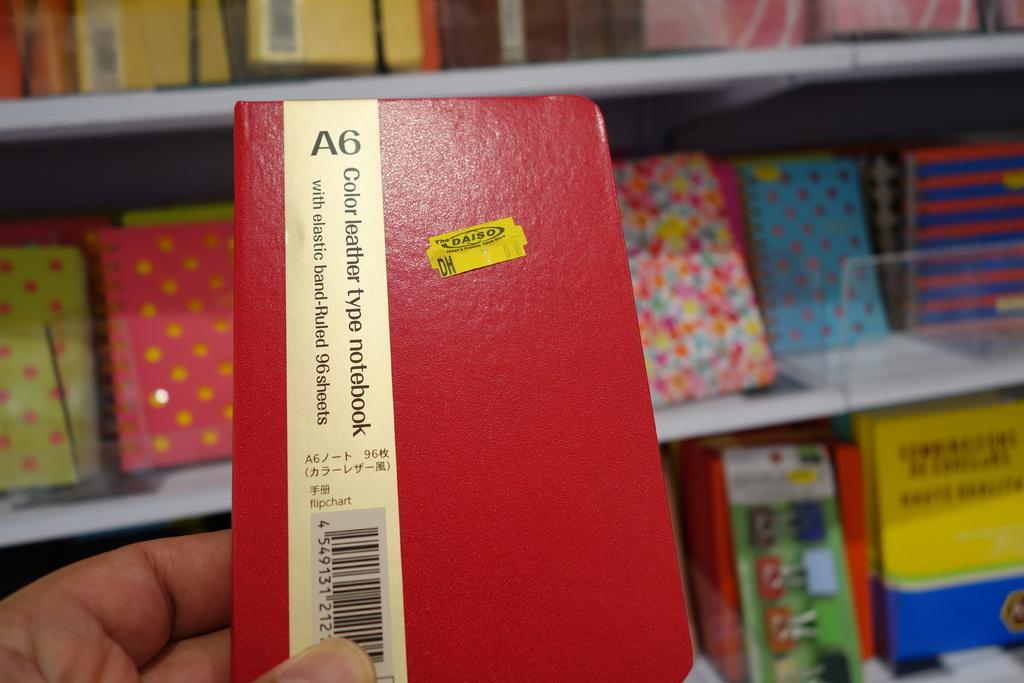<image>
Offer a succinct explanation of the picture presented. A red leather type notebook with 96 ruled sheets is being held in a hand. 